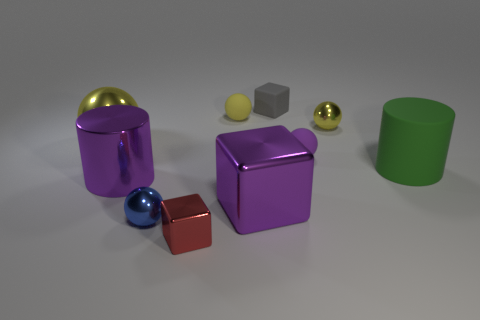Do the yellow thing that is behind the small yellow metal sphere and the large purple object that is on the right side of the blue metallic ball have the same material?
Your answer should be very brief. No. Are there any matte balls in front of the gray matte block?
Provide a short and direct response. Yes. How many cyan things are either big cubes or metallic objects?
Ensure brevity in your answer.  0. Are the small gray thing and the small yellow ball on the left side of the purple rubber object made of the same material?
Offer a very short reply. Yes. What size is the purple shiny object that is the same shape as the large green thing?
Your answer should be compact. Large. What material is the big green object?
Your response must be concise. Rubber. The tiny yellow sphere that is behind the metallic sphere to the right of the rubber ball in front of the large yellow thing is made of what material?
Keep it short and to the point. Rubber. Does the yellow metal ball that is left of the tiny yellow rubber ball have the same size as the green rubber cylinder that is in front of the rubber block?
Offer a very short reply. Yes. What number of other things are the same material as the small red cube?
Keep it short and to the point. 5. What number of metallic objects are either gray things or red blocks?
Ensure brevity in your answer.  1. 